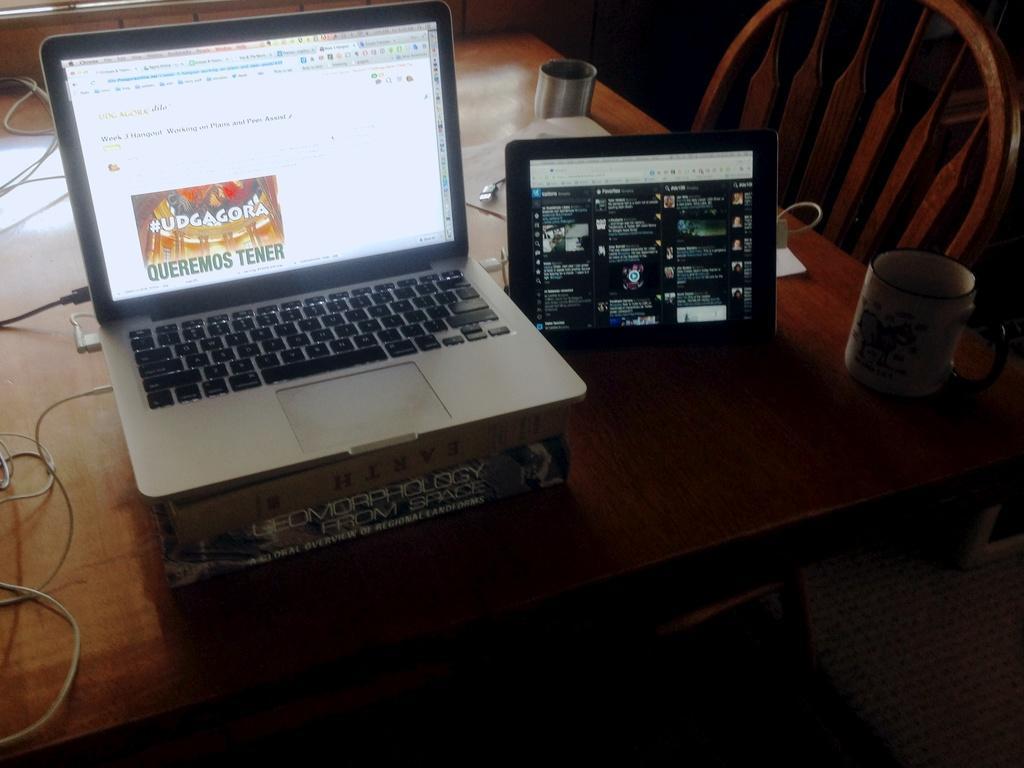In one or two sentences, can you explain what this image depicts? On this table there is a box, laptop, iPad, cup and cables. Beside this table there is a chair. 